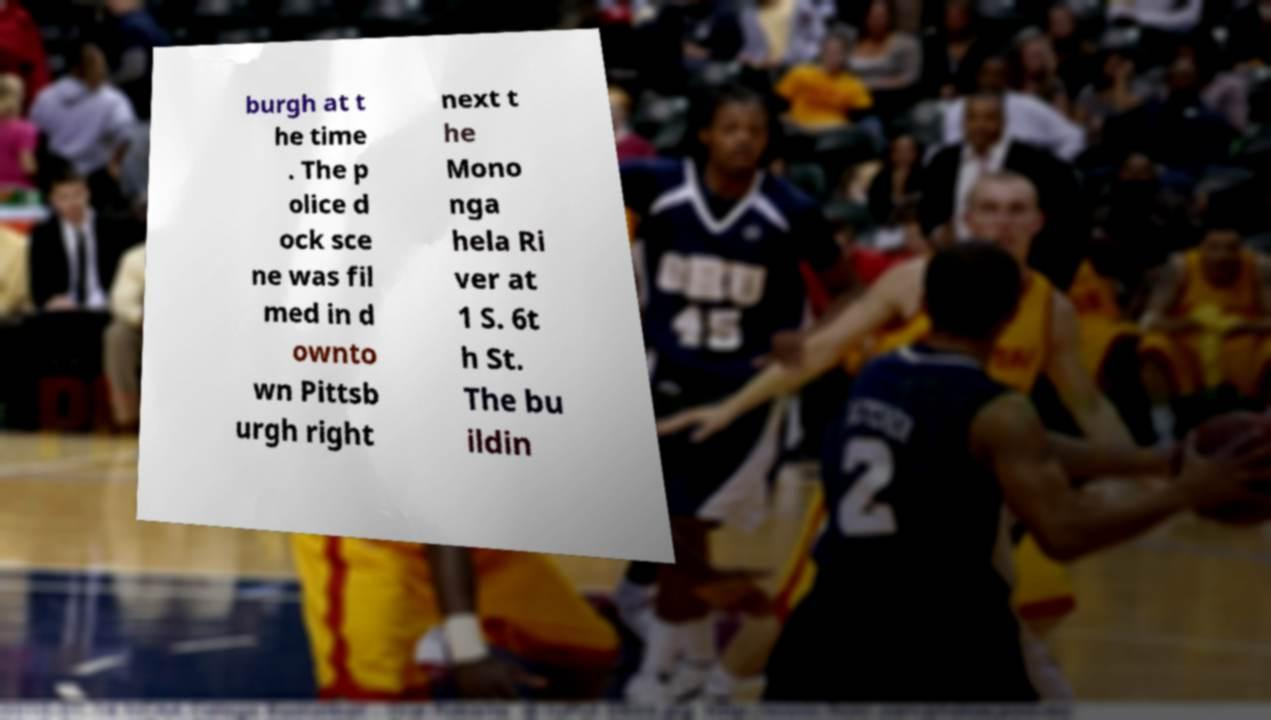There's text embedded in this image that I need extracted. Can you transcribe it verbatim? burgh at t he time . The p olice d ock sce ne was fil med in d ownto wn Pittsb urgh right next t he Mono nga hela Ri ver at 1 S. 6t h St. The bu ildin 